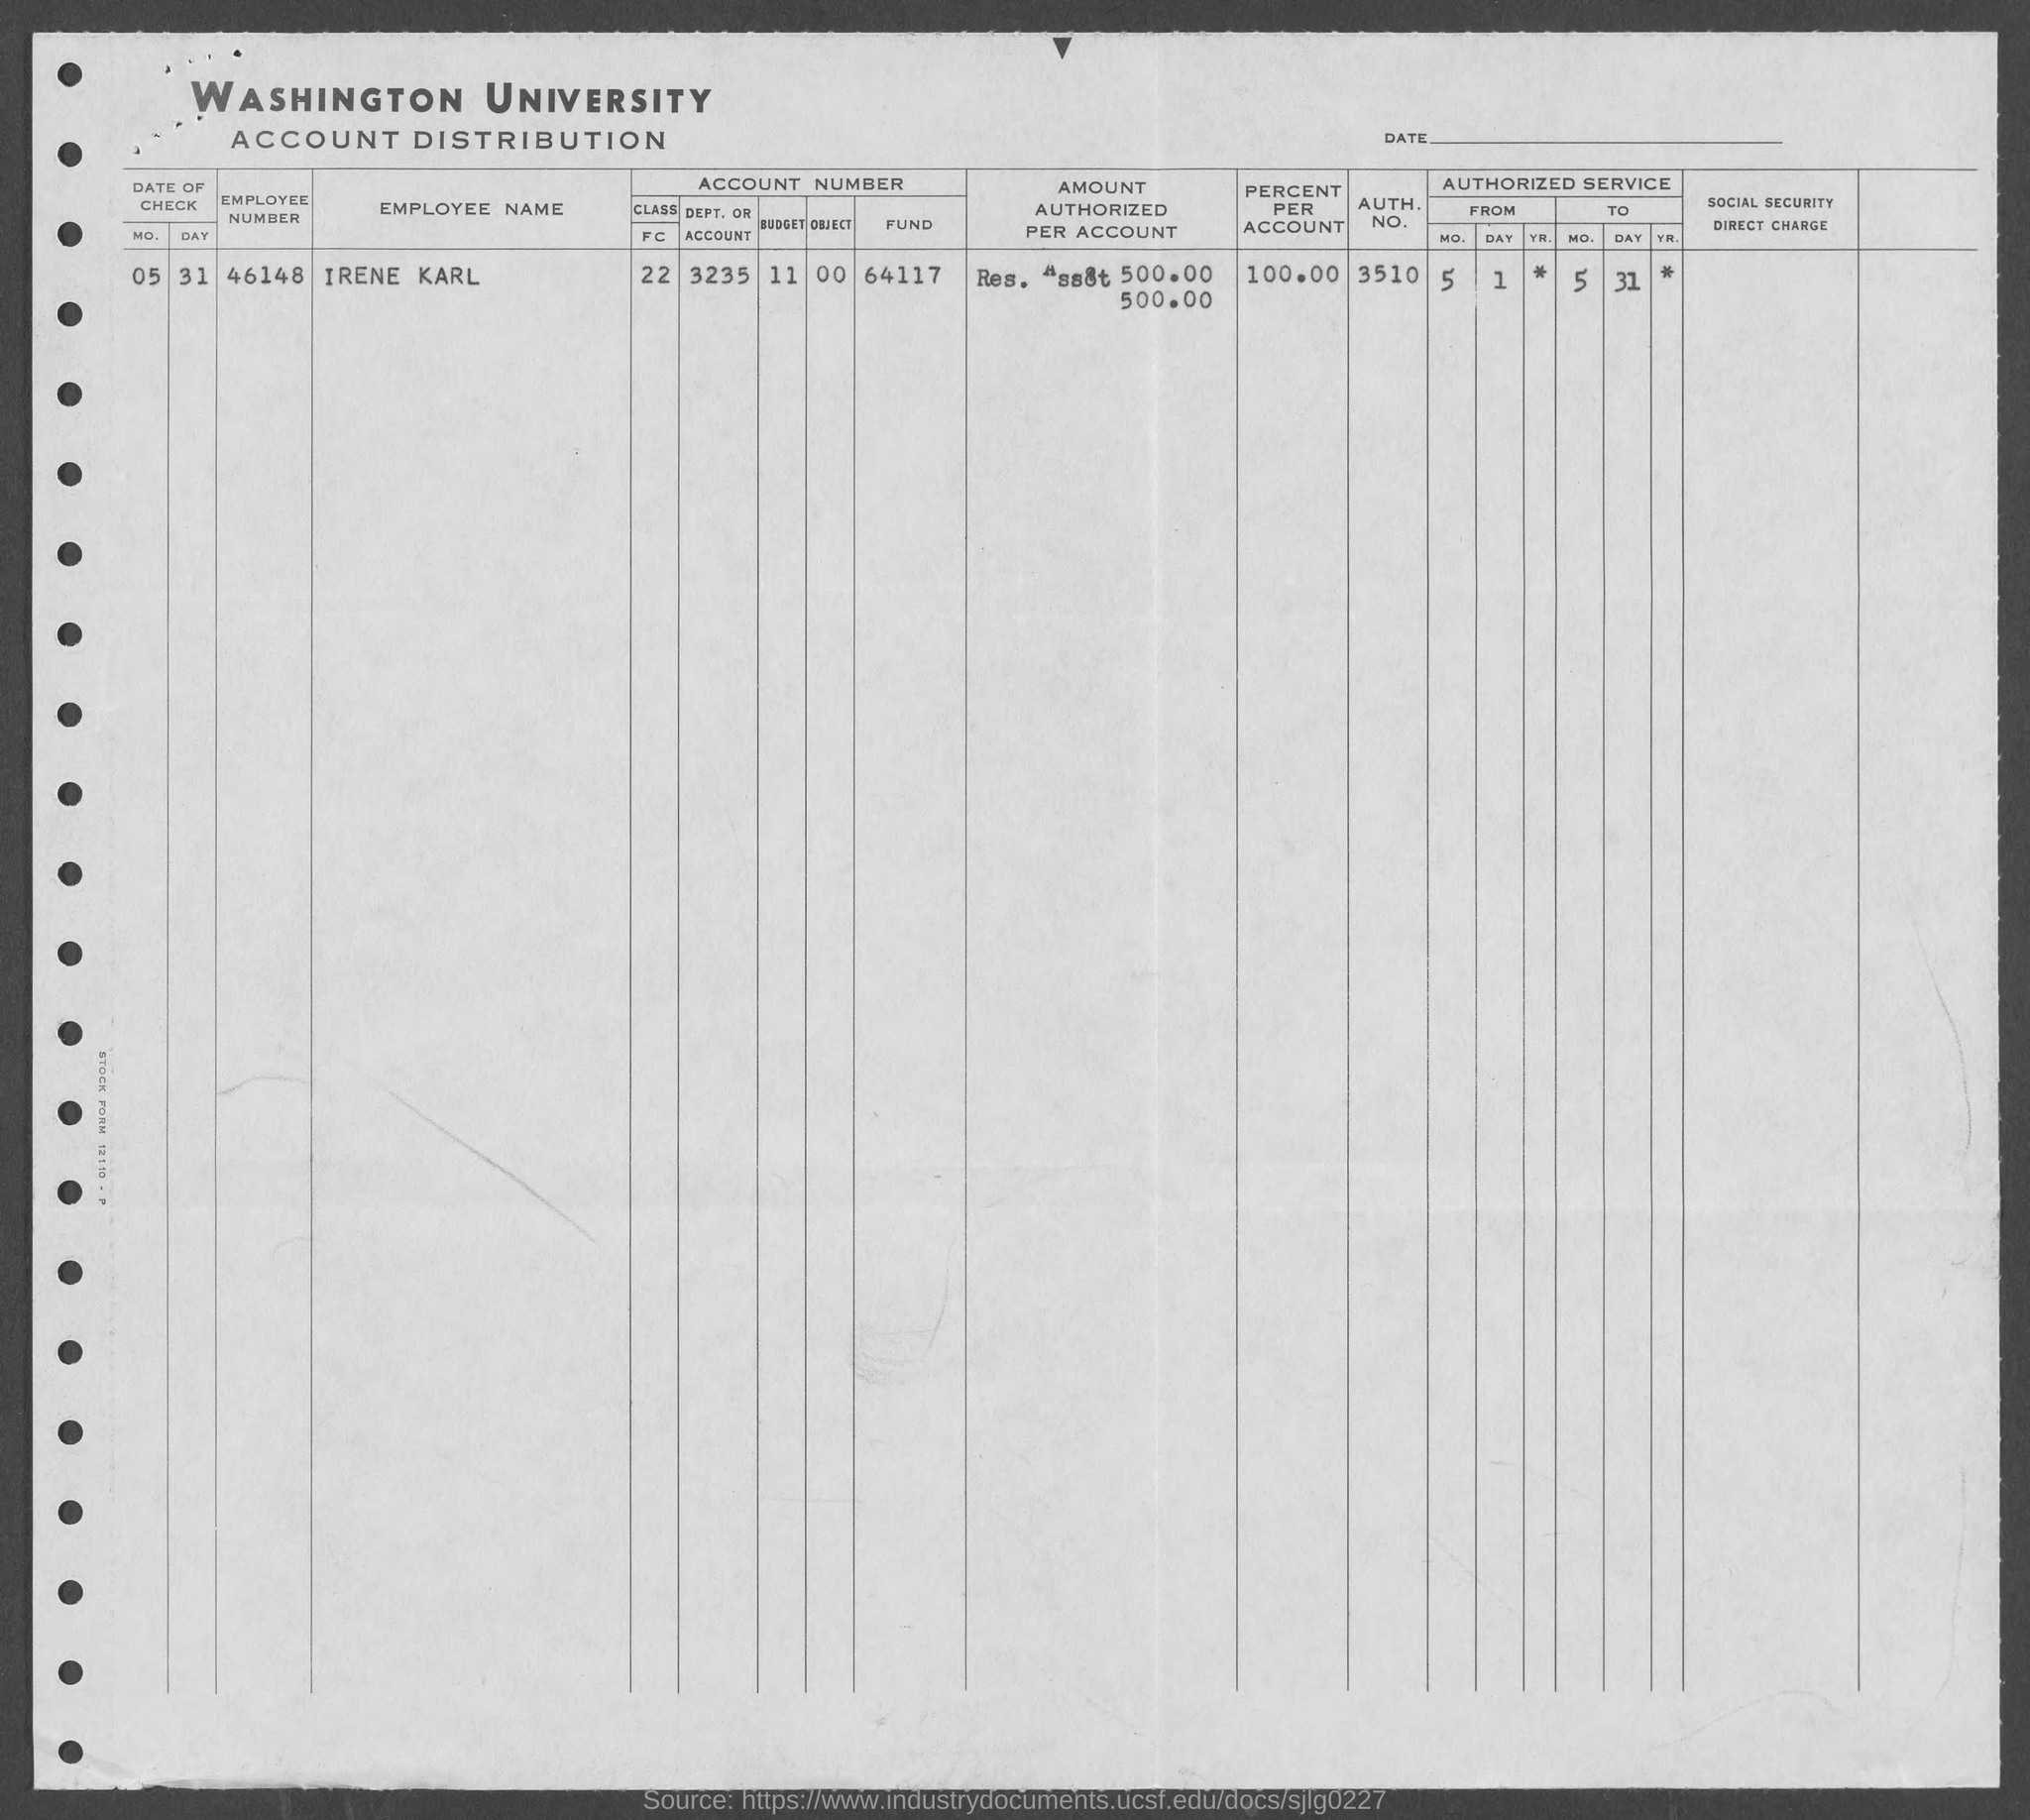List a handful of essential elements in this visual. A percentage of 100% of Irene Karl's account has been identified. The employee number of Irene Karl is 46148. Irene Karl's authorization number is 3510. 